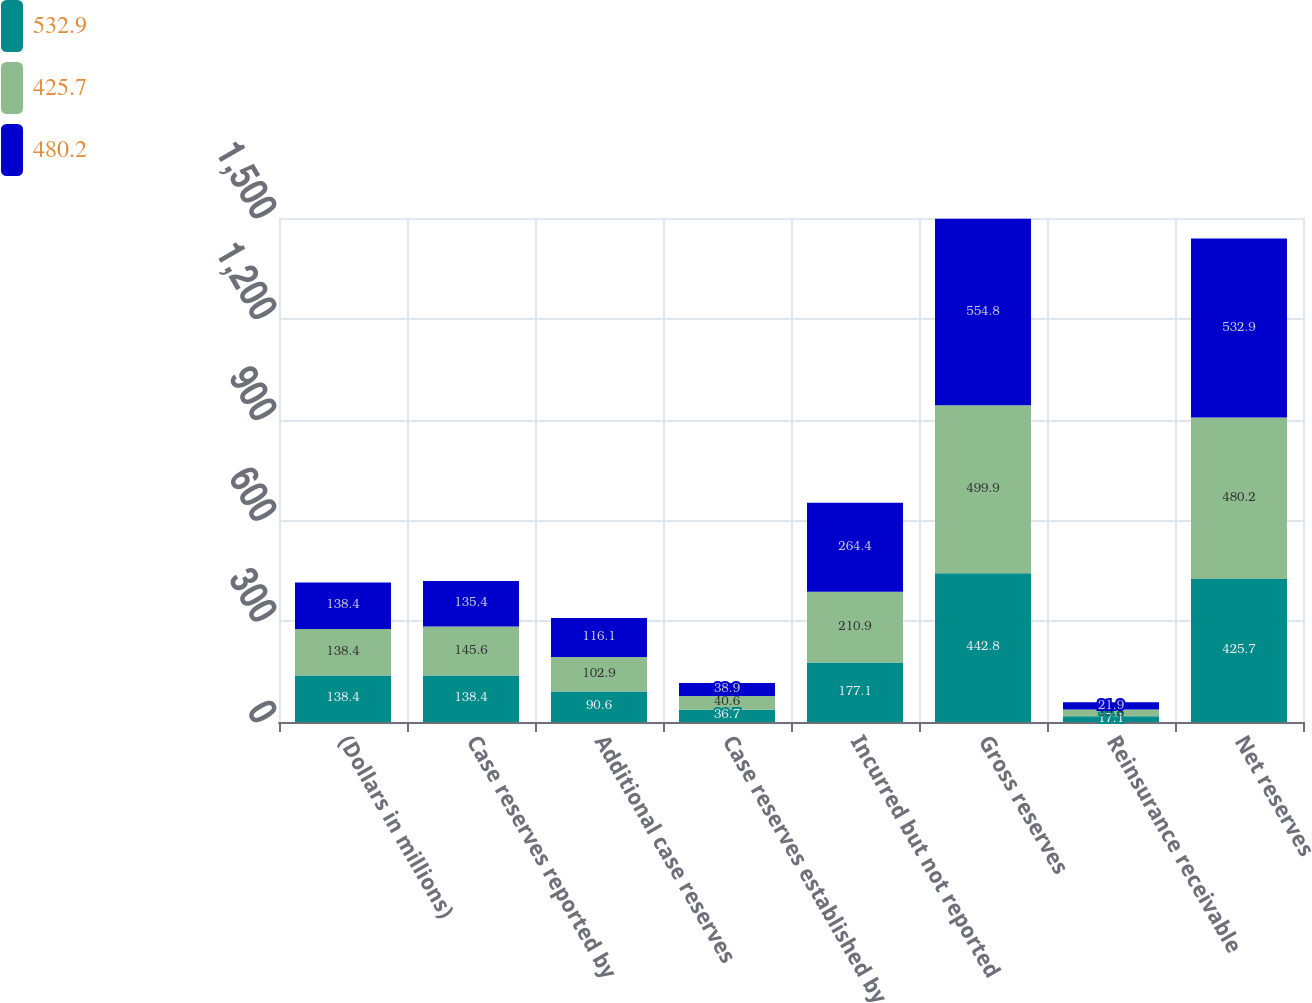<chart> <loc_0><loc_0><loc_500><loc_500><stacked_bar_chart><ecel><fcel>(Dollars in millions)<fcel>Case reserves reported by<fcel>Additional case reserves<fcel>Case reserves established by<fcel>Incurred but not reported<fcel>Gross reserves<fcel>Reinsurance receivable<fcel>Net reserves<nl><fcel>532.9<fcel>138.4<fcel>138.4<fcel>90.6<fcel>36.7<fcel>177.1<fcel>442.8<fcel>17.1<fcel>425.7<nl><fcel>425.7<fcel>138.4<fcel>145.6<fcel>102.9<fcel>40.6<fcel>210.9<fcel>499.9<fcel>19.8<fcel>480.2<nl><fcel>480.2<fcel>138.4<fcel>135.4<fcel>116.1<fcel>38.9<fcel>264.4<fcel>554.8<fcel>21.9<fcel>532.9<nl></chart> 